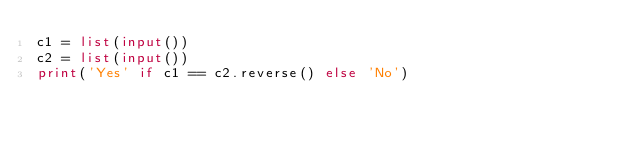<code> <loc_0><loc_0><loc_500><loc_500><_Python_>c1 = list(input())
c2 = list(input())
print('Yes' if c1 == c2.reverse() else 'No')</code> 